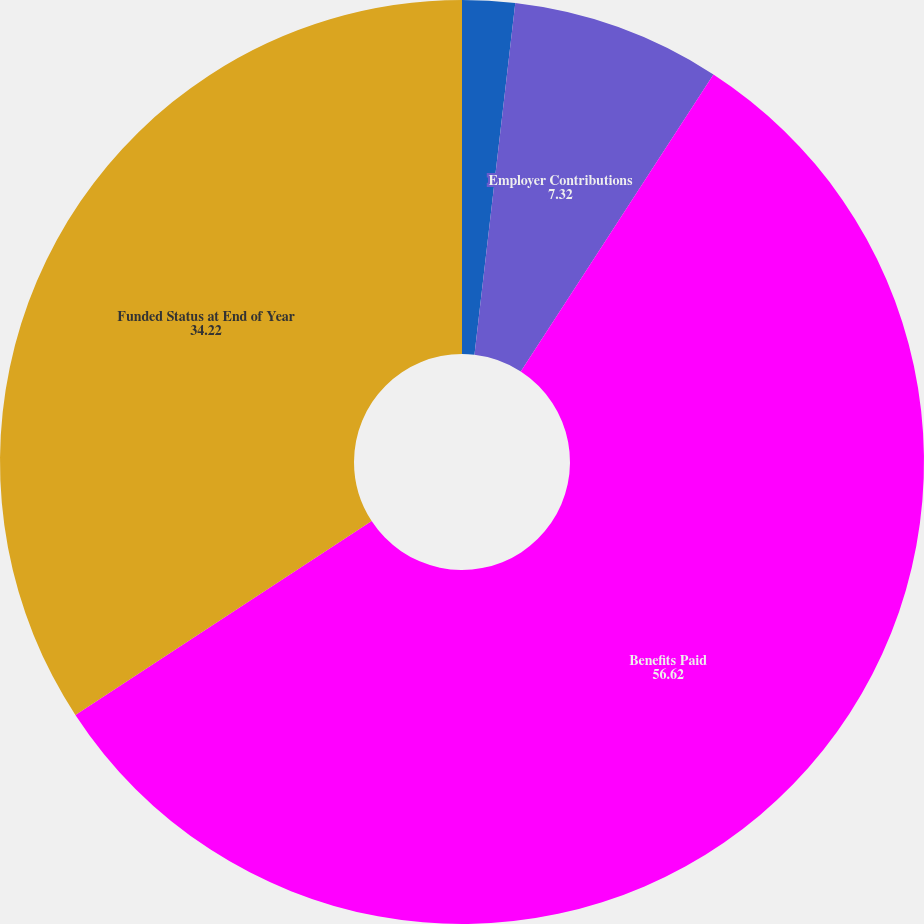Convert chart to OTSL. <chart><loc_0><loc_0><loc_500><loc_500><pie_chart><fcel>(in thousands)<fcel>Employer Contributions<fcel>Benefits Paid<fcel>Funded Status at End of Year<nl><fcel>1.84%<fcel>7.32%<fcel>56.62%<fcel>34.22%<nl></chart> 